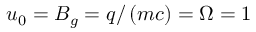<formula> <loc_0><loc_0><loc_500><loc_500>u _ { 0 } = B _ { g } = q / \left ( m c \right ) = \Omega = 1</formula> 